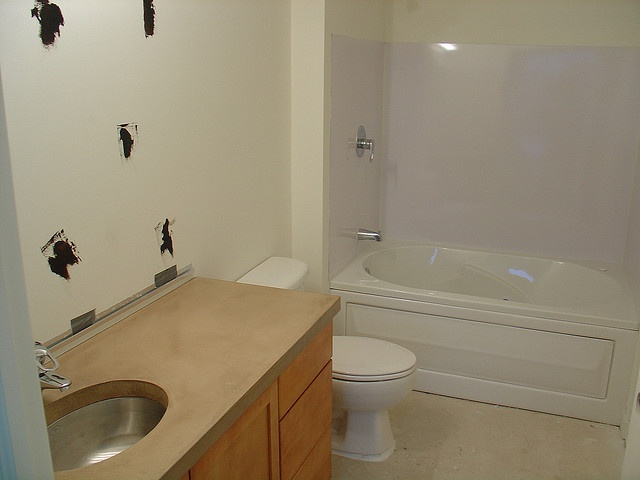Describe the objects in this image and their specific colors. I can see toilet in darkgray and gray tones and sink in darkgray, gray, maroon, and black tones in this image. 